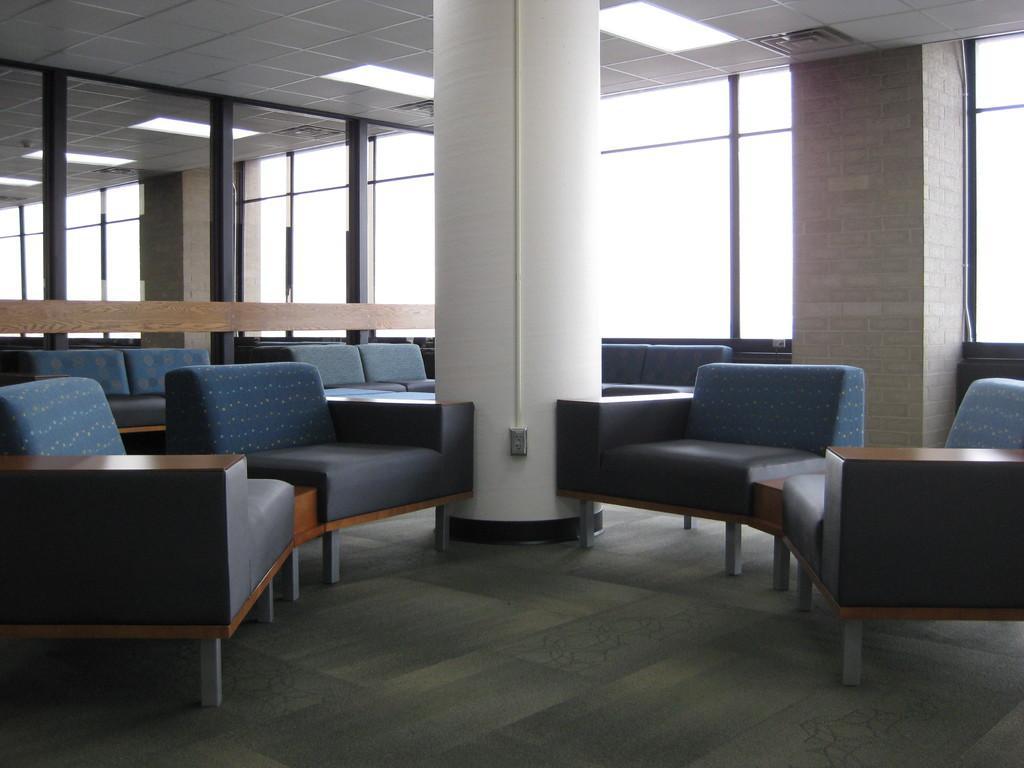Could you give a brief overview of what you see in this image? This is a picture consist of a building and there are some sofa sets kept on the floor and there is a wall visible on the right side and there is a window visible on the middle. 